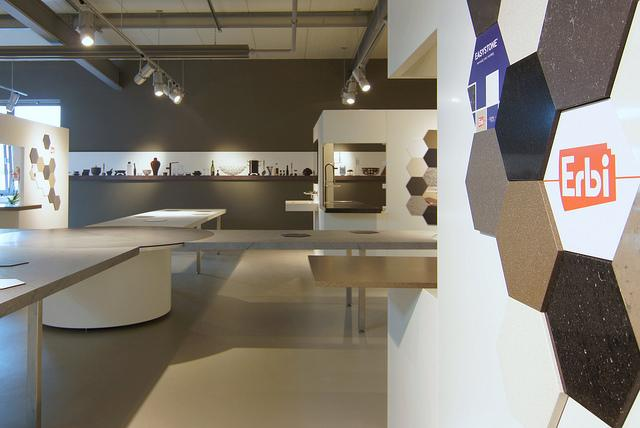This showroom specializes in which home renovation product?

Choices:
A) kitchen counters
B) cabinets
C) electronics
D) lighting kitchen counters 